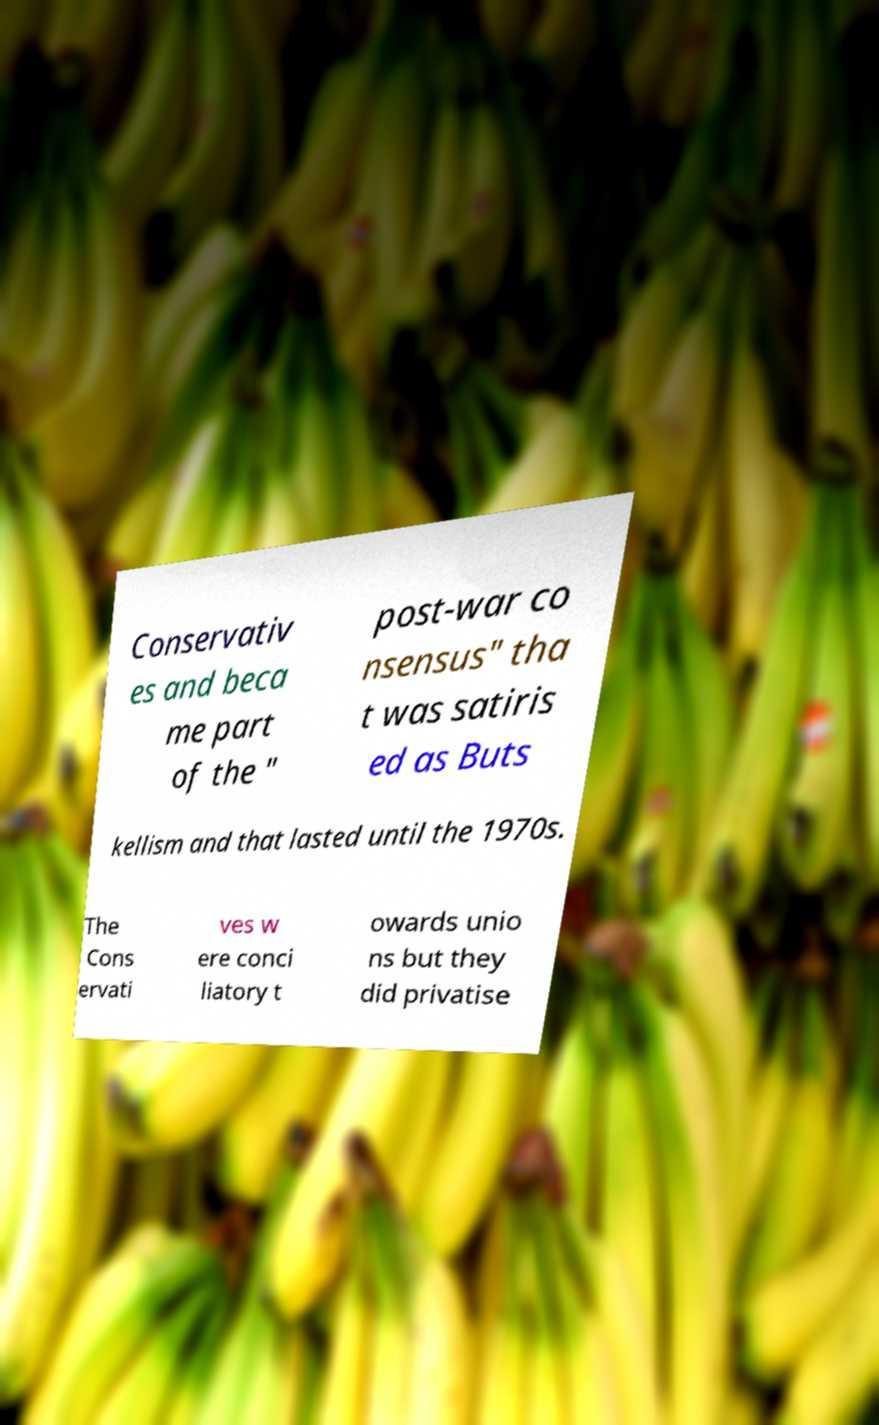Please identify and transcribe the text found in this image. Conservativ es and beca me part of the " post-war co nsensus" tha t was satiris ed as Buts kellism and that lasted until the 1970s. The Cons ervati ves w ere conci liatory t owards unio ns but they did privatise 